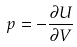Convert formula to latex. <formula><loc_0><loc_0><loc_500><loc_500>p = - \frac { \partial U } { \partial V }</formula> 